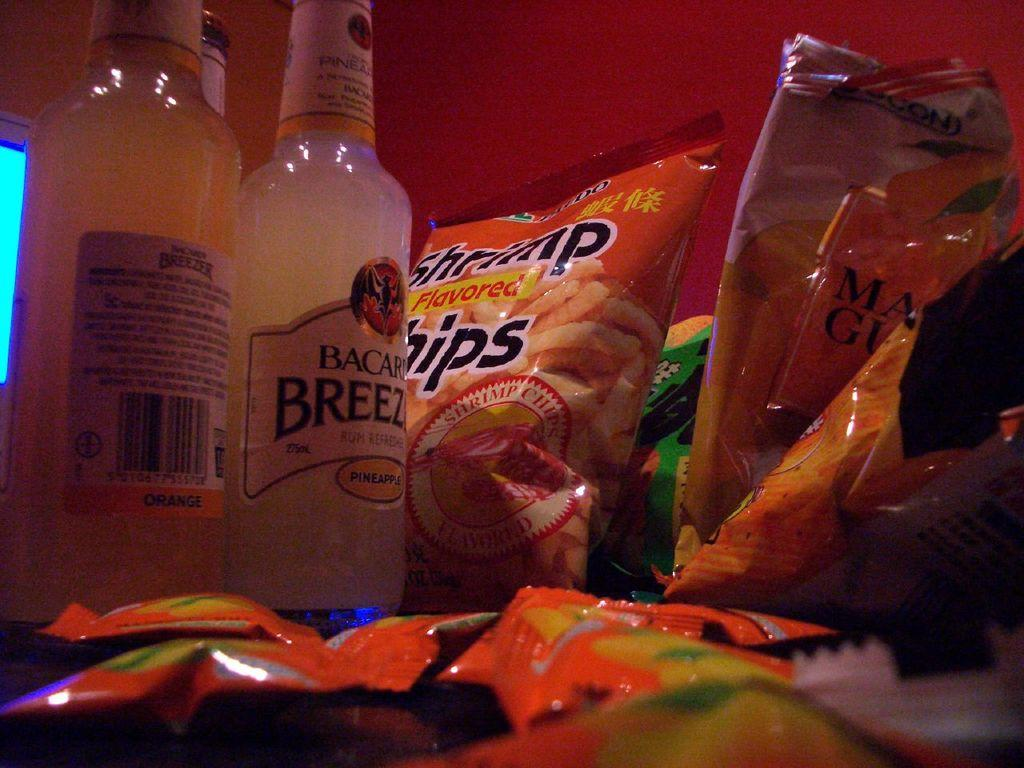<image>
Render a clear and concise summary of the photo. Two bottles of Bacardi Breeze next to a package of shrimp flavored chips and several other snack packages. 